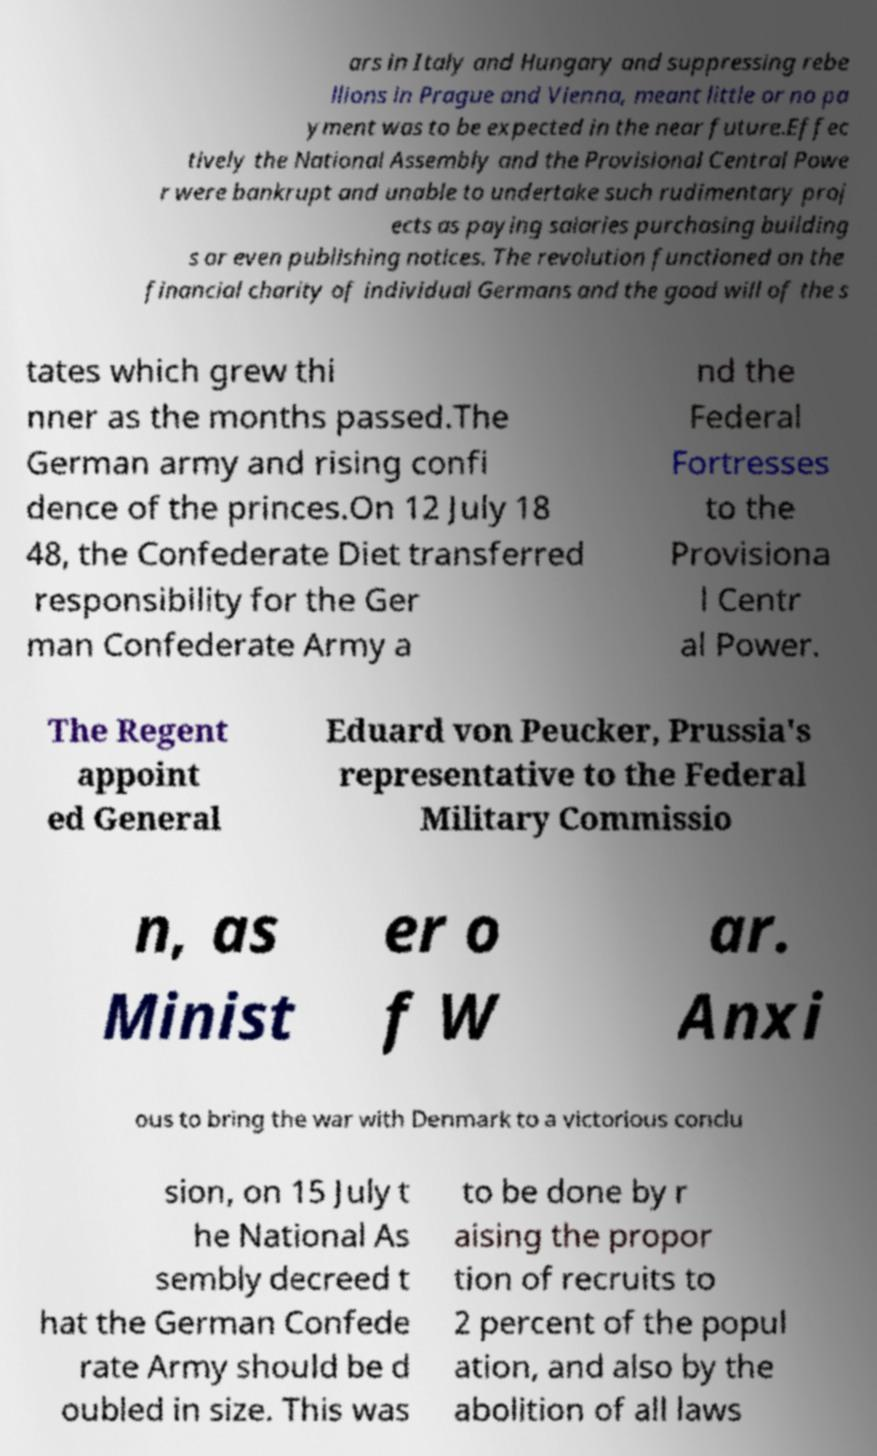Please read and relay the text visible in this image. What does it say? ars in Italy and Hungary and suppressing rebe llions in Prague and Vienna, meant little or no pa yment was to be expected in the near future.Effec tively the National Assembly and the Provisional Central Powe r were bankrupt and unable to undertake such rudimentary proj ects as paying salaries purchasing building s or even publishing notices. The revolution functioned on the financial charity of individual Germans and the good will of the s tates which grew thi nner as the months passed.The German army and rising confi dence of the princes.On 12 July 18 48, the Confederate Diet transferred responsibility for the Ger man Confederate Army a nd the Federal Fortresses to the Provisiona l Centr al Power. The Regent appoint ed General Eduard von Peucker, Prussia's representative to the Federal Military Commissio n, as Minist er o f W ar. Anxi ous to bring the war with Denmark to a victorious conclu sion, on 15 July t he National As sembly decreed t hat the German Confede rate Army should be d oubled in size. This was to be done by r aising the propor tion of recruits to 2 percent of the popul ation, and also by the abolition of all laws 